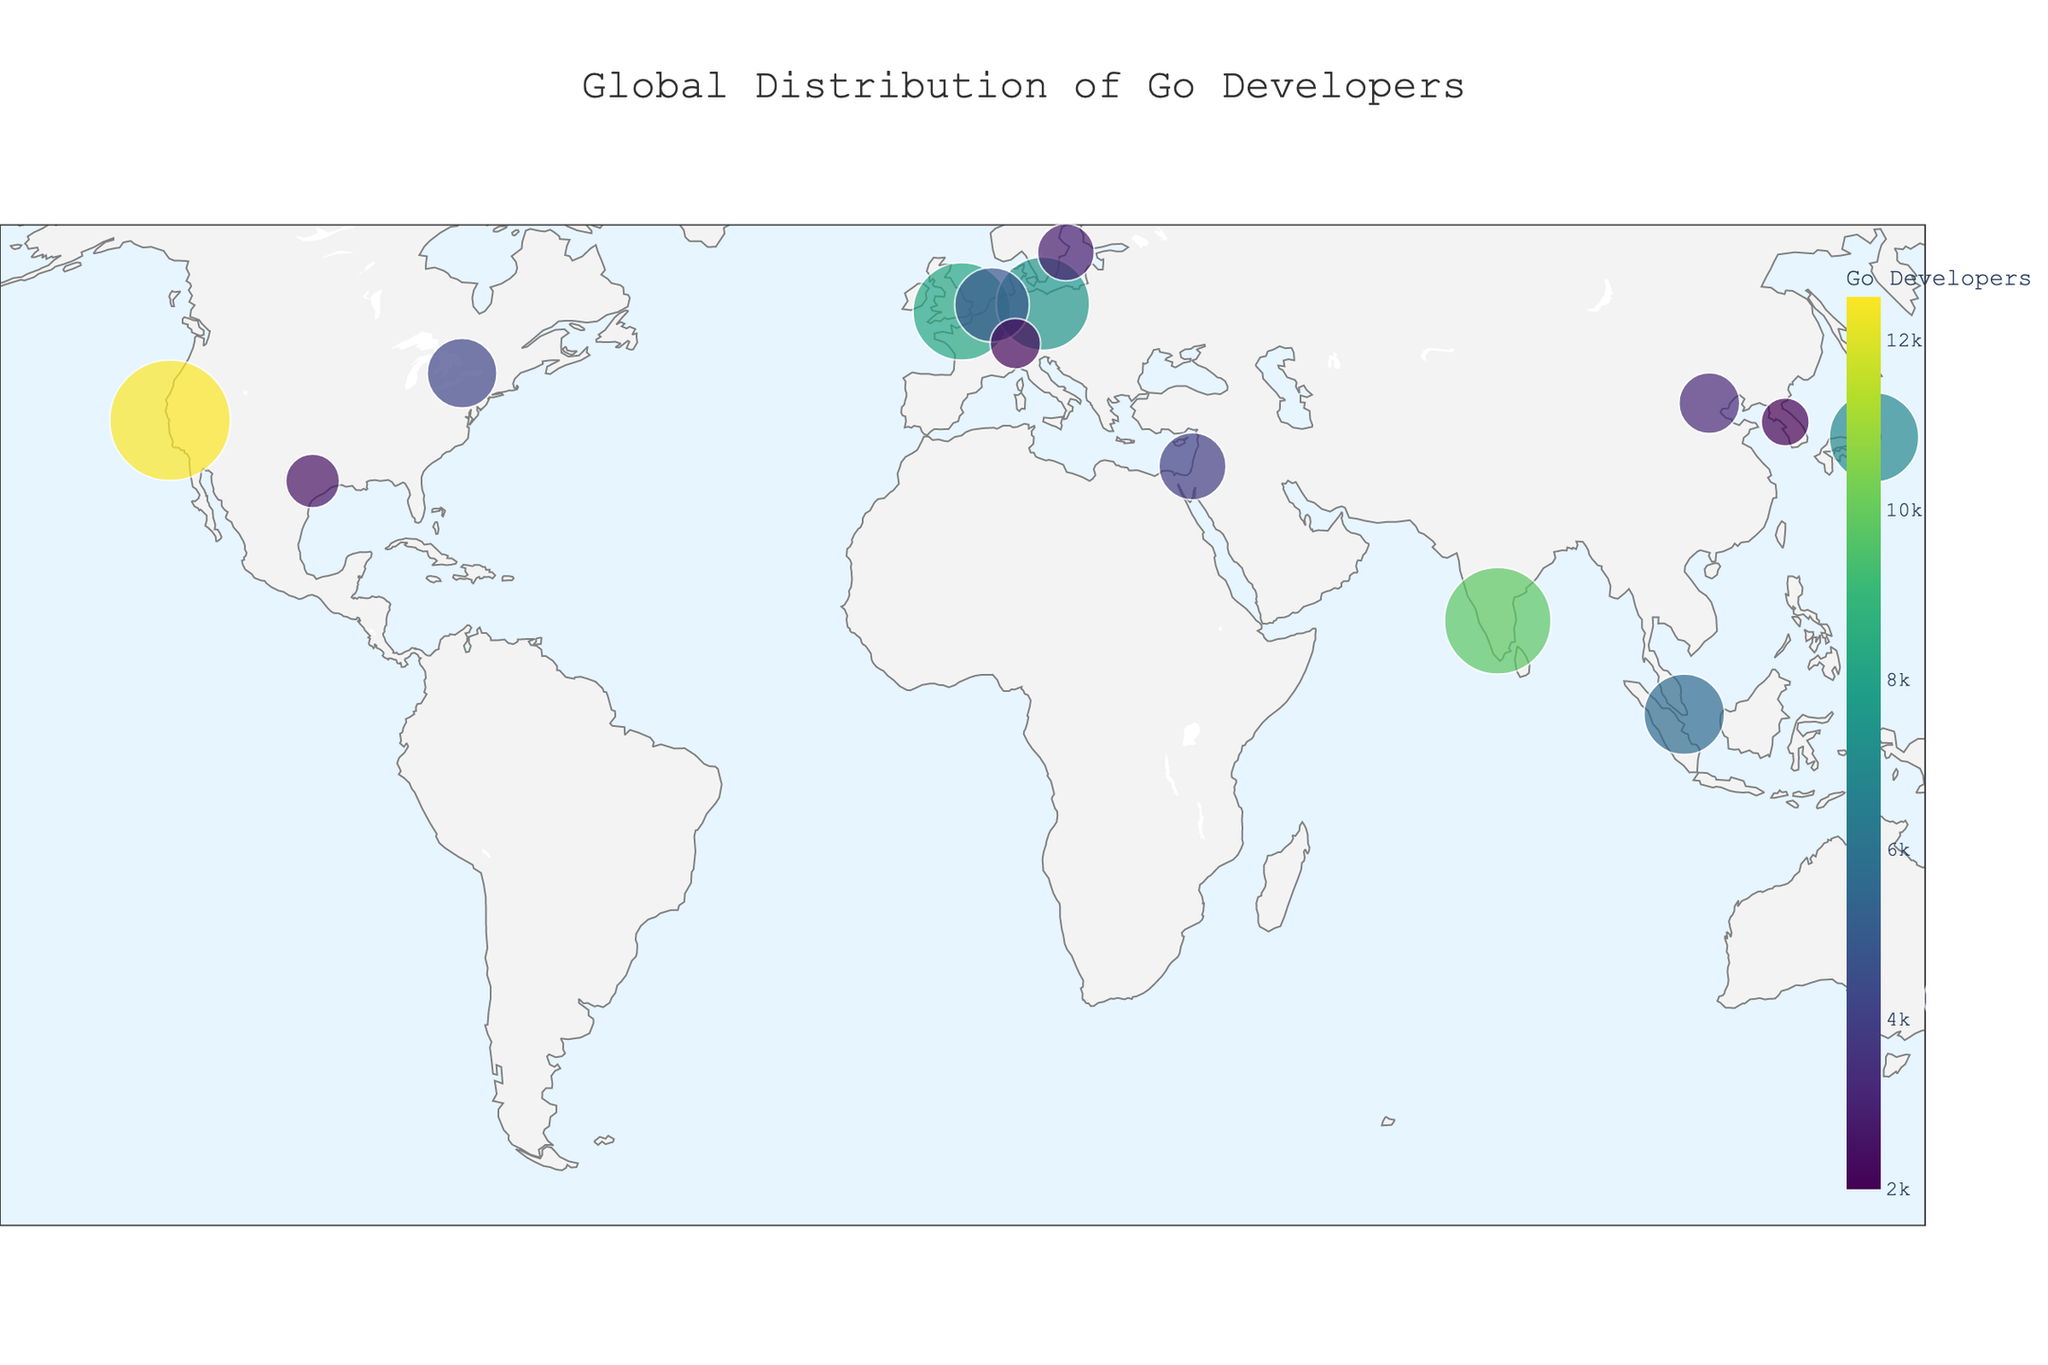What city has the highest number of Go developers? By looking at the size and color scale of the points representing each city, it's clear that the largest and darkest point corresponds to San Francisco.
Answer: San Francisco How does the number of Go developers in Bangalore compare to that in Berlin? By examining the size and color intensity of the points representing Bangalore and Berlin, it's evident that Bangalore (9800 developers) has a larger and darker point than Berlin (7500 developers).
Answer: Bangalore has more developers What is the total number of Go developers in the USA? The USA is represented by San Francisco (12500 developers) and Austin (2500 developers). Adding these numbers gives 12500 + 2500 = 15000.
Answer: 15000 Which city in Europe has the highest number of Go developers? By looking at the European cities plotted and their point sizes and colors, London stands out with 8200 developers, the highest in Europe.
Answer: London What is the most common range of Go developers count for cities in the plot? Observing the color intensity and size of the points, most cities fall in the 2000 to 5600 developers range, which is the prevalent color range in the Viridis scale and size.
Answer: 2000-5600 developers How many cities have more than 7000 Go developers? By inspecting the large and dark-colored points, we identify that San Francisco, Bangalore, London, and Berlin all have more than 7000 developers.
Answer: Four cities What is the difference in Go developer count between the largest and smallest cities on the map? The largest city, San Francisco, has 12500 developers. The smallest city, Seoul, has 2000 developers. The difference is 12500 - 2000 = 10500.
Answer: 10500 What is the average number of Go developers across all listed cities? Adding the numbers for all cities gives 12500 + 9800 + 8200 + 7500 + 6900 + 5600 + 4800 + 4200 + 3900 + 3500 + 3200 + 2800 + 2500 + 2200 + 2000 = 85500. Dividing by the 15 cities: 85500 / 15 = 5700.
Answer: 5700 Which city in Asia has the second-highest number of Go developers? By examining the Asian cities' points, Tokyo (6900 developers) comes after Bangalore, which has the highest number with 9800 developers.
Answer: Tokyo 